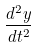Convert formula to latex. <formula><loc_0><loc_0><loc_500><loc_500>\frac { d ^ { 2 } y } { d t ^ { 2 } }</formula> 